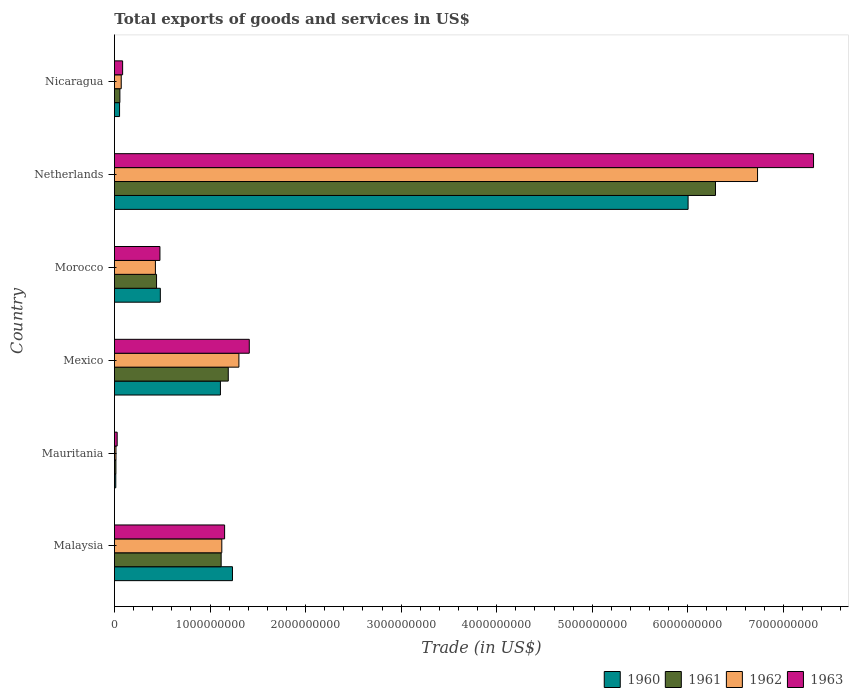How many different coloured bars are there?
Give a very brief answer. 4. How many groups of bars are there?
Your answer should be very brief. 6. Are the number of bars per tick equal to the number of legend labels?
Provide a short and direct response. Yes. Are the number of bars on each tick of the Y-axis equal?
Keep it short and to the point. Yes. How many bars are there on the 2nd tick from the top?
Ensure brevity in your answer.  4. What is the label of the 6th group of bars from the top?
Keep it short and to the point. Malaysia. What is the total exports of goods and services in 1960 in Morocco?
Your answer should be very brief. 4.80e+08. Across all countries, what is the maximum total exports of goods and services in 1961?
Make the answer very short. 6.29e+09. Across all countries, what is the minimum total exports of goods and services in 1963?
Ensure brevity in your answer.  2.87e+07. In which country was the total exports of goods and services in 1961 maximum?
Make the answer very short. Netherlands. In which country was the total exports of goods and services in 1963 minimum?
Keep it short and to the point. Mauritania. What is the total total exports of goods and services in 1963 in the graph?
Keep it short and to the point. 1.05e+1. What is the difference between the total exports of goods and services in 1960 in Mauritania and that in Netherlands?
Give a very brief answer. -5.99e+09. What is the difference between the total exports of goods and services in 1963 in Morocco and the total exports of goods and services in 1961 in Mexico?
Provide a short and direct response. -7.15e+08. What is the average total exports of goods and services in 1961 per country?
Give a very brief answer. 1.52e+09. What is the difference between the total exports of goods and services in 1963 and total exports of goods and services in 1961 in Morocco?
Keep it short and to the point. 3.56e+07. In how many countries, is the total exports of goods and services in 1960 greater than 4600000000 US$?
Provide a short and direct response. 1. What is the ratio of the total exports of goods and services in 1962 in Morocco to that in Nicaragua?
Your answer should be compact. 6.02. Is the total exports of goods and services in 1962 in Mexico less than that in Morocco?
Offer a very short reply. No. What is the difference between the highest and the second highest total exports of goods and services in 1961?
Ensure brevity in your answer.  5.10e+09. What is the difference between the highest and the lowest total exports of goods and services in 1962?
Provide a short and direct response. 6.71e+09. What does the 4th bar from the top in Netherlands represents?
Give a very brief answer. 1960. How many bars are there?
Your answer should be very brief. 24. What is the difference between two consecutive major ticks on the X-axis?
Your answer should be compact. 1.00e+09. Does the graph contain grids?
Make the answer very short. No. Where does the legend appear in the graph?
Offer a very short reply. Bottom right. What is the title of the graph?
Your answer should be compact. Total exports of goods and services in US$. What is the label or title of the X-axis?
Ensure brevity in your answer.  Trade (in US$). What is the Trade (in US$) of 1960 in Malaysia?
Your answer should be compact. 1.24e+09. What is the Trade (in US$) in 1961 in Malaysia?
Ensure brevity in your answer.  1.12e+09. What is the Trade (in US$) in 1962 in Malaysia?
Your answer should be compact. 1.12e+09. What is the Trade (in US$) of 1963 in Malaysia?
Offer a very short reply. 1.15e+09. What is the Trade (in US$) of 1960 in Mauritania?
Provide a succinct answer. 1.41e+07. What is the Trade (in US$) of 1961 in Mauritania?
Offer a very short reply. 1.54e+07. What is the Trade (in US$) in 1962 in Mauritania?
Provide a short and direct response. 1.62e+07. What is the Trade (in US$) of 1963 in Mauritania?
Provide a short and direct response. 2.87e+07. What is the Trade (in US$) of 1960 in Mexico?
Offer a very short reply. 1.11e+09. What is the Trade (in US$) in 1961 in Mexico?
Your response must be concise. 1.19e+09. What is the Trade (in US$) of 1962 in Mexico?
Your response must be concise. 1.30e+09. What is the Trade (in US$) of 1963 in Mexico?
Provide a short and direct response. 1.41e+09. What is the Trade (in US$) of 1960 in Morocco?
Keep it short and to the point. 4.80e+08. What is the Trade (in US$) in 1961 in Morocco?
Make the answer very short. 4.41e+08. What is the Trade (in US$) of 1962 in Morocco?
Your answer should be very brief. 4.29e+08. What is the Trade (in US$) of 1963 in Morocco?
Your response must be concise. 4.76e+08. What is the Trade (in US$) of 1960 in Netherlands?
Ensure brevity in your answer.  6.00e+09. What is the Trade (in US$) of 1961 in Netherlands?
Ensure brevity in your answer.  6.29e+09. What is the Trade (in US$) in 1962 in Netherlands?
Offer a terse response. 6.73e+09. What is the Trade (in US$) in 1963 in Netherlands?
Ensure brevity in your answer.  7.32e+09. What is the Trade (in US$) of 1960 in Nicaragua?
Provide a short and direct response. 5.37e+07. What is the Trade (in US$) in 1961 in Nicaragua?
Provide a short and direct response. 5.71e+07. What is the Trade (in US$) of 1962 in Nicaragua?
Your answer should be very brief. 7.12e+07. What is the Trade (in US$) of 1963 in Nicaragua?
Your response must be concise. 8.57e+07. Across all countries, what is the maximum Trade (in US$) in 1960?
Provide a short and direct response. 6.00e+09. Across all countries, what is the maximum Trade (in US$) of 1961?
Provide a succinct answer. 6.29e+09. Across all countries, what is the maximum Trade (in US$) in 1962?
Your answer should be very brief. 6.73e+09. Across all countries, what is the maximum Trade (in US$) of 1963?
Your answer should be very brief. 7.32e+09. Across all countries, what is the minimum Trade (in US$) of 1960?
Your response must be concise. 1.41e+07. Across all countries, what is the minimum Trade (in US$) in 1961?
Your answer should be compact. 1.54e+07. Across all countries, what is the minimum Trade (in US$) of 1962?
Make the answer very short. 1.62e+07. Across all countries, what is the minimum Trade (in US$) in 1963?
Ensure brevity in your answer.  2.87e+07. What is the total Trade (in US$) in 1960 in the graph?
Make the answer very short. 8.89e+09. What is the total Trade (in US$) in 1961 in the graph?
Your answer should be very brief. 9.11e+09. What is the total Trade (in US$) of 1962 in the graph?
Provide a succinct answer. 9.67e+09. What is the total Trade (in US$) of 1963 in the graph?
Your response must be concise. 1.05e+1. What is the difference between the Trade (in US$) in 1960 in Malaysia and that in Mauritania?
Make the answer very short. 1.22e+09. What is the difference between the Trade (in US$) in 1961 in Malaysia and that in Mauritania?
Your answer should be very brief. 1.10e+09. What is the difference between the Trade (in US$) in 1962 in Malaysia and that in Mauritania?
Give a very brief answer. 1.11e+09. What is the difference between the Trade (in US$) in 1963 in Malaysia and that in Mauritania?
Provide a short and direct response. 1.12e+09. What is the difference between the Trade (in US$) in 1960 in Malaysia and that in Mexico?
Keep it short and to the point. 1.26e+08. What is the difference between the Trade (in US$) of 1961 in Malaysia and that in Mexico?
Provide a short and direct response. -7.44e+07. What is the difference between the Trade (in US$) of 1962 in Malaysia and that in Mexico?
Your response must be concise. -1.79e+08. What is the difference between the Trade (in US$) of 1963 in Malaysia and that in Mexico?
Offer a terse response. -2.58e+08. What is the difference between the Trade (in US$) in 1960 in Malaysia and that in Morocco?
Keep it short and to the point. 7.55e+08. What is the difference between the Trade (in US$) in 1961 in Malaysia and that in Morocco?
Your answer should be very brief. 6.76e+08. What is the difference between the Trade (in US$) in 1962 in Malaysia and that in Morocco?
Ensure brevity in your answer.  6.95e+08. What is the difference between the Trade (in US$) in 1963 in Malaysia and that in Morocco?
Your response must be concise. 6.77e+08. What is the difference between the Trade (in US$) in 1960 in Malaysia and that in Netherlands?
Make the answer very short. -4.77e+09. What is the difference between the Trade (in US$) in 1961 in Malaysia and that in Netherlands?
Offer a terse response. -5.17e+09. What is the difference between the Trade (in US$) of 1962 in Malaysia and that in Netherlands?
Offer a terse response. -5.61e+09. What is the difference between the Trade (in US$) in 1963 in Malaysia and that in Netherlands?
Ensure brevity in your answer.  -6.16e+09. What is the difference between the Trade (in US$) in 1960 in Malaysia and that in Nicaragua?
Provide a succinct answer. 1.18e+09. What is the difference between the Trade (in US$) in 1961 in Malaysia and that in Nicaragua?
Offer a very short reply. 1.06e+09. What is the difference between the Trade (in US$) of 1962 in Malaysia and that in Nicaragua?
Keep it short and to the point. 1.05e+09. What is the difference between the Trade (in US$) of 1963 in Malaysia and that in Nicaragua?
Make the answer very short. 1.07e+09. What is the difference between the Trade (in US$) of 1960 in Mauritania and that in Mexico?
Offer a very short reply. -1.09e+09. What is the difference between the Trade (in US$) of 1961 in Mauritania and that in Mexico?
Keep it short and to the point. -1.18e+09. What is the difference between the Trade (in US$) in 1962 in Mauritania and that in Mexico?
Offer a terse response. -1.29e+09. What is the difference between the Trade (in US$) of 1963 in Mauritania and that in Mexico?
Your answer should be very brief. -1.38e+09. What is the difference between the Trade (in US$) in 1960 in Mauritania and that in Morocco?
Keep it short and to the point. -4.66e+08. What is the difference between the Trade (in US$) of 1961 in Mauritania and that in Morocco?
Provide a succinct answer. -4.25e+08. What is the difference between the Trade (in US$) of 1962 in Mauritania and that in Morocco?
Provide a short and direct response. -4.13e+08. What is the difference between the Trade (in US$) in 1963 in Mauritania and that in Morocco?
Provide a short and direct response. -4.48e+08. What is the difference between the Trade (in US$) of 1960 in Mauritania and that in Netherlands?
Provide a succinct answer. -5.99e+09. What is the difference between the Trade (in US$) of 1961 in Mauritania and that in Netherlands?
Provide a short and direct response. -6.27e+09. What is the difference between the Trade (in US$) of 1962 in Mauritania and that in Netherlands?
Offer a very short reply. -6.71e+09. What is the difference between the Trade (in US$) of 1963 in Mauritania and that in Netherlands?
Your response must be concise. -7.29e+09. What is the difference between the Trade (in US$) of 1960 in Mauritania and that in Nicaragua?
Ensure brevity in your answer.  -3.96e+07. What is the difference between the Trade (in US$) of 1961 in Mauritania and that in Nicaragua?
Your answer should be compact. -4.17e+07. What is the difference between the Trade (in US$) in 1962 in Mauritania and that in Nicaragua?
Offer a terse response. -5.50e+07. What is the difference between the Trade (in US$) in 1963 in Mauritania and that in Nicaragua?
Make the answer very short. -5.70e+07. What is the difference between the Trade (in US$) of 1960 in Mexico and that in Morocco?
Ensure brevity in your answer.  6.29e+08. What is the difference between the Trade (in US$) in 1961 in Mexico and that in Morocco?
Provide a short and direct response. 7.51e+08. What is the difference between the Trade (in US$) in 1962 in Mexico and that in Morocco?
Your answer should be very brief. 8.74e+08. What is the difference between the Trade (in US$) of 1963 in Mexico and that in Morocco?
Ensure brevity in your answer.  9.35e+08. What is the difference between the Trade (in US$) in 1960 in Mexico and that in Netherlands?
Your answer should be compact. -4.89e+09. What is the difference between the Trade (in US$) of 1961 in Mexico and that in Netherlands?
Your answer should be very brief. -5.10e+09. What is the difference between the Trade (in US$) of 1962 in Mexico and that in Netherlands?
Make the answer very short. -5.43e+09. What is the difference between the Trade (in US$) in 1963 in Mexico and that in Netherlands?
Keep it short and to the point. -5.90e+09. What is the difference between the Trade (in US$) of 1960 in Mexico and that in Nicaragua?
Offer a terse response. 1.06e+09. What is the difference between the Trade (in US$) of 1961 in Mexico and that in Nicaragua?
Ensure brevity in your answer.  1.13e+09. What is the difference between the Trade (in US$) in 1962 in Mexico and that in Nicaragua?
Provide a short and direct response. 1.23e+09. What is the difference between the Trade (in US$) in 1963 in Mexico and that in Nicaragua?
Your response must be concise. 1.33e+09. What is the difference between the Trade (in US$) of 1960 in Morocco and that in Netherlands?
Your response must be concise. -5.52e+09. What is the difference between the Trade (in US$) in 1961 in Morocco and that in Netherlands?
Offer a terse response. -5.85e+09. What is the difference between the Trade (in US$) of 1962 in Morocco and that in Netherlands?
Your answer should be compact. -6.30e+09. What is the difference between the Trade (in US$) of 1963 in Morocco and that in Netherlands?
Your answer should be compact. -6.84e+09. What is the difference between the Trade (in US$) of 1960 in Morocco and that in Nicaragua?
Make the answer very short. 4.26e+08. What is the difference between the Trade (in US$) in 1961 in Morocco and that in Nicaragua?
Offer a terse response. 3.84e+08. What is the difference between the Trade (in US$) of 1962 in Morocco and that in Nicaragua?
Offer a terse response. 3.58e+08. What is the difference between the Trade (in US$) of 1963 in Morocco and that in Nicaragua?
Offer a terse response. 3.91e+08. What is the difference between the Trade (in US$) of 1960 in Netherlands and that in Nicaragua?
Offer a very short reply. 5.95e+09. What is the difference between the Trade (in US$) in 1961 in Netherlands and that in Nicaragua?
Give a very brief answer. 6.23e+09. What is the difference between the Trade (in US$) in 1962 in Netherlands and that in Nicaragua?
Offer a terse response. 6.66e+09. What is the difference between the Trade (in US$) in 1963 in Netherlands and that in Nicaragua?
Your answer should be very brief. 7.23e+09. What is the difference between the Trade (in US$) of 1960 in Malaysia and the Trade (in US$) of 1961 in Mauritania?
Your answer should be compact. 1.22e+09. What is the difference between the Trade (in US$) of 1960 in Malaysia and the Trade (in US$) of 1962 in Mauritania?
Give a very brief answer. 1.22e+09. What is the difference between the Trade (in US$) of 1960 in Malaysia and the Trade (in US$) of 1963 in Mauritania?
Ensure brevity in your answer.  1.21e+09. What is the difference between the Trade (in US$) in 1961 in Malaysia and the Trade (in US$) in 1962 in Mauritania?
Keep it short and to the point. 1.10e+09. What is the difference between the Trade (in US$) in 1961 in Malaysia and the Trade (in US$) in 1963 in Mauritania?
Your answer should be compact. 1.09e+09. What is the difference between the Trade (in US$) in 1962 in Malaysia and the Trade (in US$) in 1963 in Mauritania?
Your answer should be very brief. 1.09e+09. What is the difference between the Trade (in US$) of 1960 in Malaysia and the Trade (in US$) of 1961 in Mexico?
Make the answer very short. 4.39e+07. What is the difference between the Trade (in US$) in 1960 in Malaysia and the Trade (in US$) in 1962 in Mexico?
Ensure brevity in your answer.  -6.74e+07. What is the difference between the Trade (in US$) in 1960 in Malaysia and the Trade (in US$) in 1963 in Mexico?
Keep it short and to the point. -1.76e+08. What is the difference between the Trade (in US$) of 1961 in Malaysia and the Trade (in US$) of 1962 in Mexico?
Give a very brief answer. -1.86e+08. What is the difference between the Trade (in US$) of 1961 in Malaysia and the Trade (in US$) of 1963 in Mexico?
Ensure brevity in your answer.  -2.94e+08. What is the difference between the Trade (in US$) in 1962 in Malaysia and the Trade (in US$) in 1963 in Mexico?
Offer a very short reply. -2.87e+08. What is the difference between the Trade (in US$) of 1960 in Malaysia and the Trade (in US$) of 1961 in Morocco?
Your answer should be compact. 7.94e+08. What is the difference between the Trade (in US$) of 1960 in Malaysia and the Trade (in US$) of 1962 in Morocco?
Your answer should be very brief. 8.06e+08. What is the difference between the Trade (in US$) of 1960 in Malaysia and the Trade (in US$) of 1963 in Morocco?
Provide a succinct answer. 7.59e+08. What is the difference between the Trade (in US$) in 1961 in Malaysia and the Trade (in US$) in 1962 in Morocco?
Your response must be concise. 6.88e+08. What is the difference between the Trade (in US$) in 1961 in Malaysia and the Trade (in US$) in 1963 in Morocco?
Ensure brevity in your answer.  6.41e+08. What is the difference between the Trade (in US$) in 1962 in Malaysia and the Trade (in US$) in 1963 in Morocco?
Your answer should be compact. 6.47e+08. What is the difference between the Trade (in US$) of 1960 in Malaysia and the Trade (in US$) of 1961 in Netherlands?
Offer a terse response. -5.05e+09. What is the difference between the Trade (in US$) of 1960 in Malaysia and the Trade (in US$) of 1962 in Netherlands?
Offer a terse response. -5.49e+09. What is the difference between the Trade (in US$) in 1960 in Malaysia and the Trade (in US$) in 1963 in Netherlands?
Provide a succinct answer. -6.08e+09. What is the difference between the Trade (in US$) of 1961 in Malaysia and the Trade (in US$) of 1962 in Netherlands?
Keep it short and to the point. -5.61e+09. What is the difference between the Trade (in US$) of 1961 in Malaysia and the Trade (in US$) of 1963 in Netherlands?
Ensure brevity in your answer.  -6.20e+09. What is the difference between the Trade (in US$) in 1962 in Malaysia and the Trade (in US$) in 1963 in Netherlands?
Provide a short and direct response. -6.19e+09. What is the difference between the Trade (in US$) of 1960 in Malaysia and the Trade (in US$) of 1961 in Nicaragua?
Offer a terse response. 1.18e+09. What is the difference between the Trade (in US$) in 1960 in Malaysia and the Trade (in US$) in 1962 in Nicaragua?
Ensure brevity in your answer.  1.16e+09. What is the difference between the Trade (in US$) in 1960 in Malaysia and the Trade (in US$) in 1963 in Nicaragua?
Provide a short and direct response. 1.15e+09. What is the difference between the Trade (in US$) in 1961 in Malaysia and the Trade (in US$) in 1962 in Nicaragua?
Ensure brevity in your answer.  1.05e+09. What is the difference between the Trade (in US$) in 1961 in Malaysia and the Trade (in US$) in 1963 in Nicaragua?
Ensure brevity in your answer.  1.03e+09. What is the difference between the Trade (in US$) of 1962 in Malaysia and the Trade (in US$) of 1963 in Nicaragua?
Provide a short and direct response. 1.04e+09. What is the difference between the Trade (in US$) in 1960 in Mauritania and the Trade (in US$) in 1961 in Mexico?
Offer a terse response. -1.18e+09. What is the difference between the Trade (in US$) of 1960 in Mauritania and the Trade (in US$) of 1962 in Mexico?
Your answer should be very brief. -1.29e+09. What is the difference between the Trade (in US$) of 1960 in Mauritania and the Trade (in US$) of 1963 in Mexico?
Make the answer very short. -1.40e+09. What is the difference between the Trade (in US$) of 1961 in Mauritania and the Trade (in US$) of 1962 in Mexico?
Offer a terse response. -1.29e+09. What is the difference between the Trade (in US$) of 1961 in Mauritania and the Trade (in US$) of 1963 in Mexico?
Provide a succinct answer. -1.40e+09. What is the difference between the Trade (in US$) in 1962 in Mauritania and the Trade (in US$) in 1963 in Mexico?
Your answer should be very brief. -1.39e+09. What is the difference between the Trade (in US$) in 1960 in Mauritania and the Trade (in US$) in 1961 in Morocco?
Make the answer very short. -4.27e+08. What is the difference between the Trade (in US$) in 1960 in Mauritania and the Trade (in US$) in 1962 in Morocco?
Your answer should be very brief. -4.15e+08. What is the difference between the Trade (in US$) in 1960 in Mauritania and the Trade (in US$) in 1963 in Morocco?
Your response must be concise. -4.62e+08. What is the difference between the Trade (in US$) of 1961 in Mauritania and the Trade (in US$) of 1962 in Morocco?
Your answer should be very brief. -4.13e+08. What is the difference between the Trade (in US$) in 1961 in Mauritania and the Trade (in US$) in 1963 in Morocco?
Your answer should be compact. -4.61e+08. What is the difference between the Trade (in US$) in 1962 in Mauritania and the Trade (in US$) in 1963 in Morocco?
Offer a very short reply. -4.60e+08. What is the difference between the Trade (in US$) in 1960 in Mauritania and the Trade (in US$) in 1961 in Netherlands?
Offer a very short reply. -6.27e+09. What is the difference between the Trade (in US$) of 1960 in Mauritania and the Trade (in US$) of 1962 in Netherlands?
Ensure brevity in your answer.  -6.72e+09. What is the difference between the Trade (in US$) of 1960 in Mauritania and the Trade (in US$) of 1963 in Netherlands?
Your response must be concise. -7.30e+09. What is the difference between the Trade (in US$) in 1961 in Mauritania and the Trade (in US$) in 1962 in Netherlands?
Ensure brevity in your answer.  -6.71e+09. What is the difference between the Trade (in US$) in 1961 in Mauritania and the Trade (in US$) in 1963 in Netherlands?
Ensure brevity in your answer.  -7.30e+09. What is the difference between the Trade (in US$) in 1962 in Mauritania and the Trade (in US$) in 1963 in Netherlands?
Make the answer very short. -7.30e+09. What is the difference between the Trade (in US$) in 1960 in Mauritania and the Trade (in US$) in 1961 in Nicaragua?
Offer a terse response. -4.30e+07. What is the difference between the Trade (in US$) of 1960 in Mauritania and the Trade (in US$) of 1962 in Nicaragua?
Offer a very short reply. -5.70e+07. What is the difference between the Trade (in US$) of 1960 in Mauritania and the Trade (in US$) of 1963 in Nicaragua?
Offer a very short reply. -7.16e+07. What is the difference between the Trade (in US$) in 1961 in Mauritania and the Trade (in US$) in 1962 in Nicaragua?
Offer a terse response. -5.57e+07. What is the difference between the Trade (in US$) of 1961 in Mauritania and the Trade (in US$) of 1963 in Nicaragua?
Your answer should be very brief. -7.03e+07. What is the difference between the Trade (in US$) of 1962 in Mauritania and the Trade (in US$) of 1963 in Nicaragua?
Your answer should be compact. -6.95e+07. What is the difference between the Trade (in US$) of 1960 in Mexico and the Trade (in US$) of 1961 in Morocco?
Offer a terse response. 6.68e+08. What is the difference between the Trade (in US$) of 1960 in Mexico and the Trade (in US$) of 1962 in Morocco?
Offer a terse response. 6.80e+08. What is the difference between the Trade (in US$) of 1960 in Mexico and the Trade (in US$) of 1963 in Morocco?
Offer a terse response. 6.33e+08. What is the difference between the Trade (in US$) of 1961 in Mexico and the Trade (in US$) of 1962 in Morocco?
Ensure brevity in your answer.  7.62e+08. What is the difference between the Trade (in US$) in 1961 in Mexico and the Trade (in US$) in 1963 in Morocco?
Your response must be concise. 7.15e+08. What is the difference between the Trade (in US$) in 1962 in Mexico and the Trade (in US$) in 1963 in Morocco?
Ensure brevity in your answer.  8.26e+08. What is the difference between the Trade (in US$) of 1960 in Mexico and the Trade (in US$) of 1961 in Netherlands?
Give a very brief answer. -5.18e+09. What is the difference between the Trade (in US$) of 1960 in Mexico and the Trade (in US$) of 1962 in Netherlands?
Provide a succinct answer. -5.62e+09. What is the difference between the Trade (in US$) in 1960 in Mexico and the Trade (in US$) in 1963 in Netherlands?
Provide a short and direct response. -6.21e+09. What is the difference between the Trade (in US$) of 1961 in Mexico and the Trade (in US$) of 1962 in Netherlands?
Your answer should be compact. -5.54e+09. What is the difference between the Trade (in US$) of 1961 in Mexico and the Trade (in US$) of 1963 in Netherlands?
Keep it short and to the point. -6.12e+09. What is the difference between the Trade (in US$) in 1962 in Mexico and the Trade (in US$) in 1963 in Netherlands?
Make the answer very short. -6.01e+09. What is the difference between the Trade (in US$) in 1960 in Mexico and the Trade (in US$) in 1961 in Nicaragua?
Provide a short and direct response. 1.05e+09. What is the difference between the Trade (in US$) in 1960 in Mexico and the Trade (in US$) in 1962 in Nicaragua?
Offer a terse response. 1.04e+09. What is the difference between the Trade (in US$) of 1960 in Mexico and the Trade (in US$) of 1963 in Nicaragua?
Provide a succinct answer. 1.02e+09. What is the difference between the Trade (in US$) in 1961 in Mexico and the Trade (in US$) in 1962 in Nicaragua?
Your response must be concise. 1.12e+09. What is the difference between the Trade (in US$) of 1961 in Mexico and the Trade (in US$) of 1963 in Nicaragua?
Keep it short and to the point. 1.11e+09. What is the difference between the Trade (in US$) of 1962 in Mexico and the Trade (in US$) of 1963 in Nicaragua?
Offer a terse response. 1.22e+09. What is the difference between the Trade (in US$) of 1960 in Morocco and the Trade (in US$) of 1961 in Netherlands?
Make the answer very short. -5.81e+09. What is the difference between the Trade (in US$) of 1960 in Morocco and the Trade (in US$) of 1962 in Netherlands?
Ensure brevity in your answer.  -6.25e+09. What is the difference between the Trade (in US$) of 1960 in Morocco and the Trade (in US$) of 1963 in Netherlands?
Your response must be concise. -6.83e+09. What is the difference between the Trade (in US$) in 1961 in Morocco and the Trade (in US$) in 1962 in Netherlands?
Provide a succinct answer. -6.29e+09. What is the difference between the Trade (in US$) of 1961 in Morocco and the Trade (in US$) of 1963 in Netherlands?
Ensure brevity in your answer.  -6.87e+09. What is the difference between the Trade (in US$) of 1962 in Morocco and the Trade (in US$) of 1963 in Netherlands?
Provide a short and direct response. -6.89e+09. What is the difference between the Trade (in US$) in 1960 in Morocco and the Trade (in US$) in 1961 in Nicaragua?
Offer a very short reply. 4.23e+08. What is the difference between the Trade (in US$) of 1960 in Morocco and the Trade (in US$) of 1962 in Nicaragua?
Your answer should be compact. 4.09e+08. What is the difference between the Trade (in US$) of 1960 in Morocco and the Trade (in US$) of 1963 in Nicaragua?
Give a very brief answer. 3.94e+08. What is the difference between the Trade (in US$) in 1961 in Morocco and the Trade (in US$) in 1962 in Nicaragua?
Provide a succinct answer. 3.69e+08. What is the difference between the Trade (in US$) of 1961 in Morocco and the Trade (in US$) of 1963 in Nicaragua?
Give a very brief answer. 3.55e+08. What is the difference between the Trade (in US$) in 1962 in Morocco and the Trade (in US$) in 1963 in Nicaragua?
Keep it short and to the point. 3.43e+08. What is the difference between the Trade (in US$) of 1960 in Netherlands and the Trade (in US$) of 1961 in Nicaragua?
Provide a short and direct response. 5.95e+09. What is the difference between the Trade (in US$) of 1960 in Netherlands and the Trade (in US$) of 1962 in Nicaragua?
Offer a very short reply. 5.93e+09. What is the difference between the Trade (in US$) of 1960 in Netherlands and the Trade (in US$) of 1963 in Nicaragua?
Give a very brief answer. 5.92e+09. What is the difference between the Trade (in US$) in 1961 in Netherlands and the Trade (in US$) in 1962 in Nicaragua?
Provide a short and direct response. 6.22e+09. What is the difference between the Trade (in US$) in 1961 in Netherlands and the Trade (in US$) in 1963 in Nicaragua?
Provide a short and direct response. 6.20e+09. What is the difference between the Trade (in US$) in 1962 in Netherlands and the Trade (in US$) in 1963 in Nicaragua?
Ensure brevity in your answer.  6.64e+09. What is the average Trade (in US$) of 1960 per country?
Your response must be concise. 1.48e+09. What is the average Trade (in US$) of 1961 per country?
Provide a short and direct response. 1.52e+09. What is the average Trade (in US$) in 1962 per country?
Offer a very short reply. 1.61e+09. What is the average Trade (in US$) of 1963 per country?
Keep it short and to the point. 1.74e+09. What is the difference between the Trade (in US$) of 1960 and Trade (in US$) of 1961 in Malaysia?
Your response must be concise. 1.18e+08. What is the difference between the Trade (in US$) in 1960 and Trade (in US$) in 1962 in Malaysia?
Provide a short and direct response. 1.11e+08. What is the difference between the Trade (in US$) in 1960 and Trade (in US$) in 1963 in Malaysia?
Your response must be concise. 8.23e+07. What is the difference between the Trade (in US$) of 1961 and Trade (in US$) of 1962 in Malaysia?
Your answer should be compact. -6.88e+06. What is the difference between the Trade (in US$) of 1961 and Trade (in US$) of 1963 in Malaysia?
Give a very brief answer. -3.60e+07. What is the difference between the Trade (in US$) of 1962 and Trade (in US$) of 1963 in Malaysia?
Make the answer very short. -2.92e+07. What is the difference between the Trade (in US$) of 1960 and Trade (in US$) of 1961 in Mauritania?
Keep it short and to the point. -1.31e+06. What is the difference between the Trade (in US$) of 1960 and Trade (in US$) of 1962 in Mauritania?
Your response must be concise. -2.02e+06. What is the difference between the Trade (in US$) of 1960 and Trade (in US$) of 1963 in Mauritania?
Ensure brevity in your answer.  -1.45e+07. What is the difference between the Trade (in US$) of 1961 and Trade (in US$) of 1962 in Mauritania?
Provide a succinct answer. -7.07e+05. What is the difference between the Trade (in US$) of 1961 and Trade (in US$) of 1963 in Mauritania?
Give a very brief answer. -1.32e+07. What is the difference between the Trade (in US$) of 1962 and Trade (in US$) of 1963 in Mauritania?
Make the answer very short. -1.25e+07. What is the difference between the Trade (in US$) of 1960 and Trade (in US$) of 1961 in Mexico?
Your response must be concise. -8.21e+07. What is the difference between the Trade (in US$) in 1960 and Trade (in US$) in 1962 in Mexico?
Offer a very short reply. -1.93e+08. What is the difference between the Trade (in US$) in 1960 and Trade (in US$) in 1963 in Mexico?
Your answer should be very brief. -3.02e+08. What is the difference between the Trade (in US$) in 1961 and Trade (in US$) in 1962 in Mexico?
Your answer should be very brief. -1.11e+08. What is the difference between the Trade (in US$) of 1961 and Trade (in US$) of 1963 in Mexico?
Provide a short and direct response. -2.20e+08. What is the difference between the Trade (in US$) in 1962 and Trade (in US$) in 1963 in Mexico?
Provide a succinct answer. -1.09e+08. What is the difference between the Trade (in US$) of 1960 and Trade (in US$) of 1961 in Morocco?
Provide a short and direct response. 3.95e+07. What is the difference between the Trade (in US$) in 1960 and Trade (in US$) in 1962 in Morocco?
Keep it short and to the point. 5.14e+07. What is the difference between the Trade (in US$) in 1960 and Trade (in US$) in 1963 in Morocco?
Keep it short and to the point. 3.95e+06. What is the difference between the Trade (in US$) of 1961 and Trade (in US$) of 1962 in Morocco?
Offer a terse response. 1.19e+07. What is the difference between the Trade (in US$) in 1961 and Trade (in US$) in 1963 in Morocco?
Give a very brief answer. -3.56e+07. What is the difference between the Trade (in US$) of 1962 and Trade (in US$) of 1963 in Morocco?
Offer a terse response. -4.74e+07. What is the difference between the Trade (in US$) in 1960 and Trade (in US$) in 1961 in Netherlands?
Offer a very short reply. -2.87e+08. What is the difference between the Trade (in US$) in 1960 and Trade (in US$) in 1962 in Netherlands?
Offer a terse response. -7.27e+08. What is the difference between the Trade (in US$) in 1960 and Trade (in US$) in 1963 in Netherlands?
Give a very brief answer. -1.31e+09. What is the difference between the Trade (in US$) in 1961 and Trade (in US$) in 1962 in Netherlands?
Offer a very short reply. -4.40e+08. What is the difference between the Trade (in US$) in 1961 and Trade (in US$) in 1963 in Netherlands?
Give a very brief answer. -1.03e+09. What is the difference between the Trade (in US$) of 1962 and Trade (in US$) of 1963 in Netherlands?
Offer a very short reply. -5.86e+08. What is the difference between the Trade (in US$) in 1960 and Trade (in US$) in 1961 in Nicaragua?
Keep it short and to the point. -3.39e+06. What is the difference between the Trade (in US$) in 1960 and Trade (in US$) in 1962 in Nicaragua?
Give a very brief answer. -1.74e+07. What is the difference between the Trade (in US$) in 1960 and Trade (in US$) in 1963 in Nicaragua?
Your response must be concise. -3.20e+07. What is the difference between the Trade (in US$) in 1961 and Trade (in US$) in 1962 in Nicaragua?
Provide a short and direct response. -1.40e+07. What is the difference between the Trade (in US$) of 1961 and Trade (in US$) of 1963 in Nicaragua?
Make the answer very short. -2.86e+07. What is the difference between the Trade (in US$) of 1962 and Trade (in US$) of 1963 in Nicaragua?
Your response must be concise. -1.45e+07. What is the ratio of the Trade (in US$) of 1960 in Malaysia to that in Mauritania?
Make the answer very short. 87.37. What is the ratio of the Trade (in US$) in 1961 in Malaysia to that in Mauritania?
Give a very brief answer. 72.29. What is the ratio of the Trade (in US$) in 1962 in Malaysia to that in Mauritania?
Keep it short and to the point. 69.56. What is the ratio of the Trade (in US$) of 1963 in Malaysia to that in Mauritania?
Offer a very short reply. 40.2. What is the ratio of the Trade (in US$) in 1960 in Malaysia to that in Mexico?
Offer a very short reply. 1.11. What is the ratio of the Trade (in US$) of 1962 in Malaysia to that in Mexico?
Make the answer very short. 0.86. What is the ratio of the Trade (in US$) in 1963 in Malaysia to that in Mexico?
Provide a short and direct response. 0.82. What is the ratio of the Trade (in US$) in 1960 in Malaysia to that in Morocco?
Keep it short and to the point. 2.57. What is the ratio of the Trade (in US$) in 1961 in Malaysia to that in Morocco?
Make the answer very short. 2.53. What is the ratio of the Trade (in US$) of 1962 in Malaysia to that in Morocco?
Offer a terse response. 2.62. What is the ratio of the Trade (in US$) of 1963 in Malaysia to that in Morocco?
Offer a very short reply. 2.42. What is the ratio of the Trade (in US$) in 1960 in Malaysia to that in Netherlands?
Ensure brevity in your answer.  0.21. What is the ratio of the Trade (in US$) of 1961 in Malaysia to that in Netherlands?
Provide a short and direct response. 0.18. What is the ratio of the Trade (in US$) in 1962 in Malaysia to that in Netherlands?
Provide a short and direct response. 0.17. What is the ratio of the Trade (in US$) of 1963 in Malaysia to that in Netherlands?
Provide a short and direct response. 0.16. What is the ratio of the Trade (in US$) of 1960 in Malaysia to that in Nicaragua?
Offer a terse response. 22.98. What is the ratio of the Trade (in US$) of 1961 in Malaysia to that in Nicaragua?
Make the answer very short. 19.55. What is the ratio of the Trade (in US$) in 1962 in Malaysia to that in Nicaragua?
Your answer should be very brief. 15.79. What is the ratio of the Trade (in US$) in 1963 in Malaysia to that in Nicaragua?
Ensure brevity in your answer.  13.45. What is the ratio of the Trade (in US$) in 1960 in Mauritania to that in Mexico?
Provide a short and direct response. 0.01. What is the ratio of the Trade (in US$) of 1961 in Mauritania to that in Mexico?
Offer a very short reply. 0.01. What is the ratio of the Trade (in US$) of 1962 in Mauritania to that in Mexico?
Offer a very short reply. 0.01. What is the ratio of the Trade (in US$) of 1963 in Mauritania to that in Mexico?
Offer a terse response. 0.02. What is the ratio of the Trade (in US$) in 1960 in Mauritania to that in Morocco?
Provide a succinct answer. 0.03. What is the ratio of the Trade (in US$) in 1961 in Mauritania to that in Morocco?
Keep it short and to the point. 0.04. What is the ratio of the Trade (in US$) in 1962 in Mauritania to that in Morocco?
Give a very brief answer. 0.04. What is the ratio of the Trade (in US$) in 1963 in Mauritania to that in Morocco?
Ensure brevity in your answer.  0.06. What is the ratio of the Trade (in US$) in 1960 in Mauritania to that in Netherlands?
Your answer should be compact. 0. What is the ratio of the Trade (in US$) in 1961 in Mauritania to that in Netherlands?
Make the answer very short. 0. What is the ratio of the Trade (in US$) of 1962 in Mauritania to that in Netherlands?
Provide a succinct answer. 0. What is the ratio of the Trade (in US$) in 1963 in Mauritania to that in Netherlands?
Your response must be concise. 0. What is the ratio of the Trade (in US$) in 1960 in Mauritania to that in Nicaragua?
Your answer should be compact. 0.26. What is the ratio of the Trade (in US$) of 1961 in Mauritania to that in Nicaragua?
Make the answer very short. 0.27. What is the ratio of the Trade (in US$) of 1962 in Mauritania to that in Nicaragua?
Keep it short and to the point. 0.23. What is the ratio of the Trade (in US$) in 1963 in Mauritania to that in Nicaragua?
Offer a terse response. 0.33. What is the ratio of the Trade (in US$) of 1960 in Mexico to that in Morocco?
Your response must be concise. 2.31. What is the ratio of the Trade (in US$) of 1961 in Mexico to that in Morocco?
Provide a short and direct response. 2.7. What is the ratio of the Trade (in US$) of 1962 in Mexico to that in Morocco?
Keep it short and to the point. 3.04. What is the ratio of the Trade (in US$) of 1963 in Mexico to that in Morocco?
Provide a short and direct response. 2.96. What is the ratio of the Trade (in US$) in 1960 in Mexico to that in Netherlands?
Provide a short and direct response. 0.18. What is the ratio of the Trade (in US$) of 1961 in Mexico to that in Netherlands?
Ensure brevity in your answer.  0.19. What is the ratio of the Trade (in US$) in 1962 in Mexico to that in Netherlands?
Offer a very short reply. 0.19. What is the ratio of the Trade (in US$) of 1963 in Mexico to that in Netherlands?
Provide a succinct answer. 0.19. What is the ratio of the Trade (in US$) of 1960 in Mexico to that in Nicaragua?
Provide a succinct answer. 20.64. What is the ratio of the Trade (in US$) of 1961 in Mexico to that in Nicaragua?
Keep it short and to the point. 20.85. What is the ratio of the Trade (in US$) of 1962 in Mexico to that in Nicaragua?
Your answer should be very brief. 18.3. What is the ratio of the Trade (in US$) of 1963 in Mexico to that in Nicaragua?
Your response must be concise. 16.47. What is the ratio of the Trade (in US$) in 1961 in Morocco to that in Netherlands?
Keep it short and to the point. 0.07. What is the ratio of the Trade (in US$) of 1962 in Morocco to that in Netherlands?
Ensure brevity in your answer.  0.06. What is the ratio of the Trade (in US$) in 1963 in Morocco to that in Netherlands?
Provide a succinct answer. 0.07. What is the ratio of the Trade (in US$) of 1960 in Morocco to that in Nicaragua?
Offer a terse response. 8.93. What is the ratio of the Trade (in US$) of 1961 in Morocco to that in Nicaragua?
Your response must be concise. 7.71. What is the ratio of the Trade (in US$) of 1962 in Morocco to that in Nicaragua?
Your answer should be very brief. 6.02. What is the ratio of the Trade (in US$) of 1963 in Morocco to that in Nicaragua?
Make the answer very short. 5.56. What is the ratio of the Trade (in US$) in 1960 in Netherlands to that in Nicaragua?
Provide a succinct answer. 111.69. What is the ratio of the Trade (in US$) of 1961 in Netherlands to that in Nicaragua?
Make the answer very short. 110.08. What is the ratio of the Trade (in US$) in 1962 in Netherlands to that in Nicaragua?
Make the answer very short. 94.54. What is the ratio of the Trade (in US$) in 1963 in Netherlands to that in Nicaragua?
Your answer should be compact. 85.36. What is the difference between the highest and the second highest Trade (in US$) of 1960?
Keep it short and to the point. 4.77e+09. What is the difference between the highest and the second highest Trade (in US$) in 1961?
Ensure brevity in your answer.  5.10e+09. What is the difference between the highest and the second highest Trade (in US$) in 1962?
Your response must be concise. 5.43e+09. What is the difference between the highest and the second highest Trade (in US$) in 1963?
Your answer should be compact. 5.90e+09. What is the difference between the highest and the lowest Trade (in US$) in 1960?
Offer a terse response. 5.99e+09. What is the difference between the highest and the lowest Trade (in US$) of 1961?
Your answer should be very brief. 6.27e+09. What is the difference between the highest and the lowest Trade (in US$) in 1962?
Your response must be concise. 6.71e+09. What is the difference between the highest and the lowest Trade (in US$) in 1963?
Make the answer very short. 7.29e+09. 